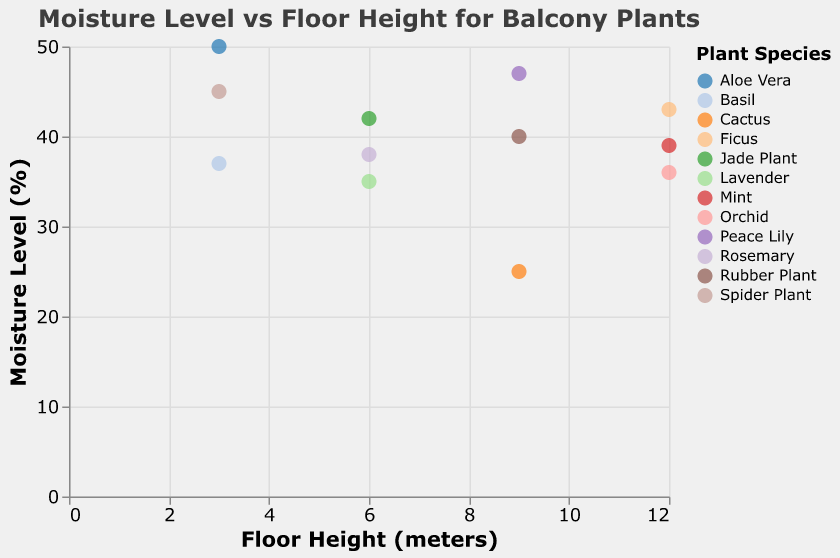What is the title of the plot? The title is prominently displayed at the top of the plot and is styled to stand out.
Answer: Moisture Level vs Floor Height for Balcony Plants How many plant species are represented in the scatter plot? Each plant species is represented by a unique color in the legend, which is helpful for counting.
Answer: 12 Which plant species have the lowest moisture level? Identify the point with the lowest value on the y-axis and refer to its tooltip or legend color.
Answer: Cactus What is the moisture level of the Lavender plant? Find the data point labeled 'Lavender' on the plot and read off the moisture level value.
Answer: 35% Which floor height has the highest variety of moisture levels? Look for the floor height with the widest range of moisture levels in the y-axis direction.
Answer: 9 meters What are the moisture levels of plants at the 12-meter floor height? Identify data points at 12 meters on the x-axis and list their moisture levels from the y-axis.
Answer: 43%, 39%, 36% What is the average moisture level of plants at the 6-meter floor height? Identify data points at 6 meters, add their moisture levels and divide by the number of points. (42+35+38)/3 = 115/3
Answer: 38.33% Which plant species have a moisture level above 40%? Identify data points with y-values above 40% and refer to their labels.
Answer: Spider Plant, Aloe Vera, Jade Plant, Peace Lily, Ficus How does the moisture level distribution change as the floor height increases? Compare the moisture levels across different floor heights and note general trends in values.
Answer: Decreases at higher floors Are there any plant species that are found at more than one floor height? Check if the same plant name appears at different x-axis values.
Answer: No 